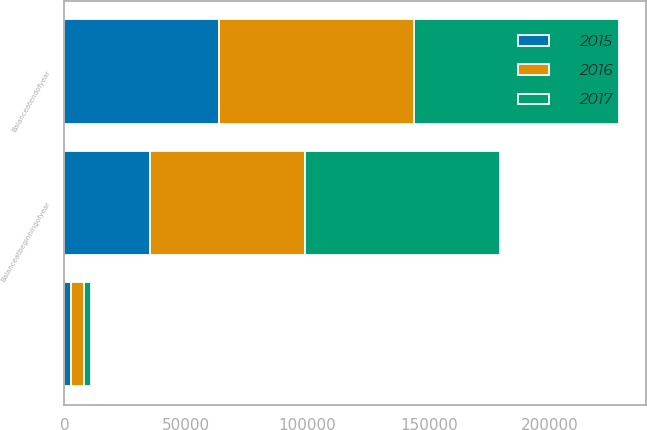Convert chart. <chart><loc_0><loc_0><loc_500><loc_500><stacked_bar_chart><ecel><fcel>Balanceatbeginningofyear<fcel>Unnamed: 2<fcel>Balanceatendofyear<nl><fcel>2017<fcel>80388<fcel>2690<fcel>84244<nl><fcel>2016<fcel>63549<fcel>5278<fcel>80388<nl><fcel>2015<fcel>35416<fcel>2777<fcel>63549<nl></chart> 